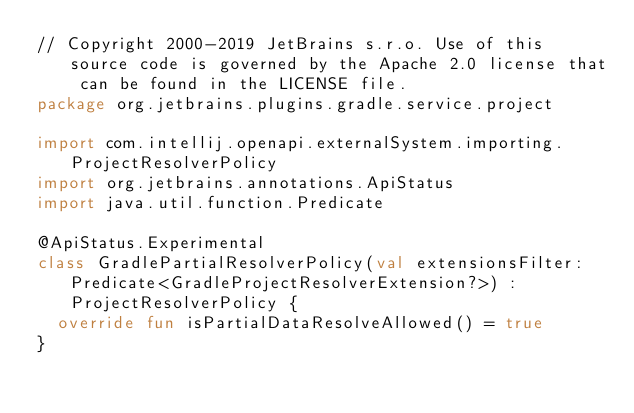Convert code to text. <code><loc_0><loc_0><loc_500><loc_500><_Kotlin_>// Copyright 2000-2019 JetBrains s.r.o. Use of this source code is governed by the Apache 2.0 license that can be found in the LICENSE file.
package org.jetbrains.plugins.gradle.service.project

import com.intellij.openapi.externalSystem.importing.ProjectResolverPolicy
import org.jetbrains.annotations.ApiStatus
import java.util.function.Predicate

@ApiStatus.Experimental
class GradlePartialResolverPolicy(val extensionsFilter: Predicate<GradleProjectResolverExtension?>) : ProjectResolverPolicy {
  override fun isPartialDataResolveAllowed() = true
}</code> 